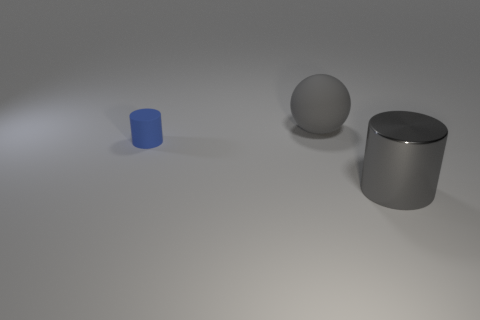What number of other objects are there of the same shape as the tiny blue thing?
Offer a very short reply. 1. There is another gray thing that is made of the same material as the tiny thing; what shape is it?
Make the answer very short. Sphere. Are any gray rubber objects visible?
Keep it short and to the point. Yes. Is the number of large rubber objects that are right of the metal object less than the number of large things that are behind the large matte thing?
Give a very brief answer. No. What is the shape of the large gray thing in front of the blue cylinder?
Make the answer very short. Cylinder. Is the gray sphere made of the same material as the blue cylinder?
Your response must be concise. Yes. Is there any other thing that has the same material as the blue cylinder?
Make the answer very short. Yes. There is a big object that is the same shape as the tiny matte object; what is its material?
Your answer should be very brief. Metal. Is the number of large gray objects that are right of the big rubber thing less than the number of small blue cubes?
Your answer should be compact. No. What number of cylinders are to the right of the rubber cylinder?
Offer a very short reply. 1. 